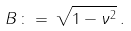<formula> <loc_0><loc_0><loc_500><loc_500>B \, \colon = \, \sqrt { 1 - \nu ^ { 2 } } \, .</formula> 